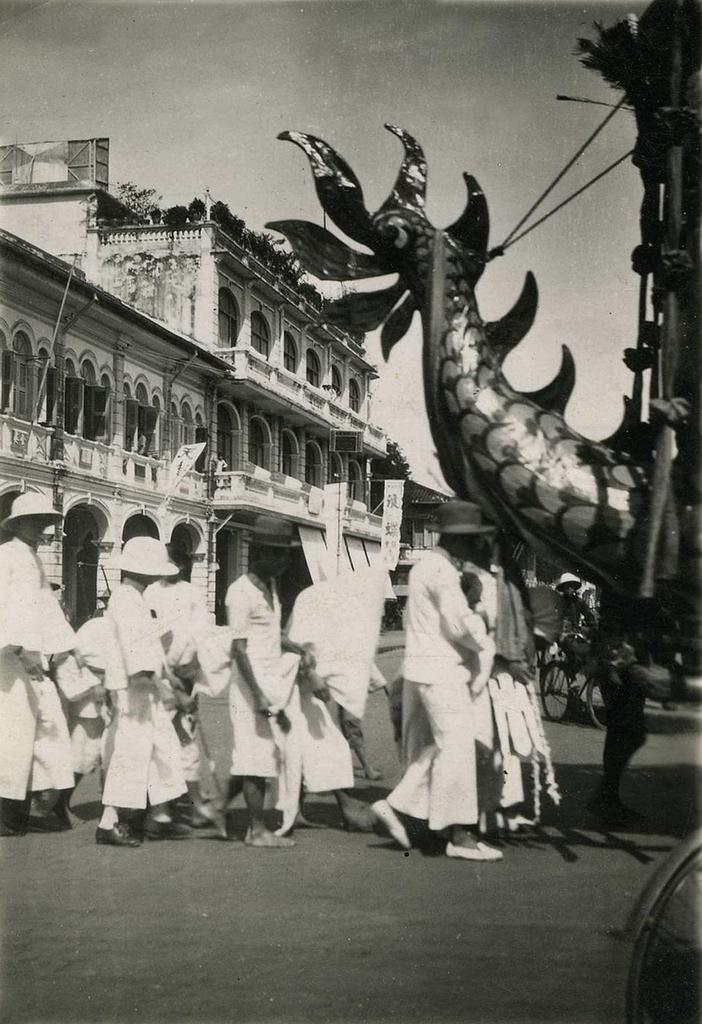What is the color scheme of the image? The image is black and white. What can be seen on the road in the image? There are people on the road in the image. What are the people wearing on their heads? The people are wearing caps. What else is present on the road besides people? There are vehicles in the image. What structures can be seen in the background? There are buildings in the image. What is visible at the top of the image? The sky is visible at the top of the image. How many pens are visible on the road in the image? There are no pens visible on the road in the image. What type of dime is being used as a decoration on the buildings in the image? There are no dimes present in the image, and they are not used as decorations on the buildings. 